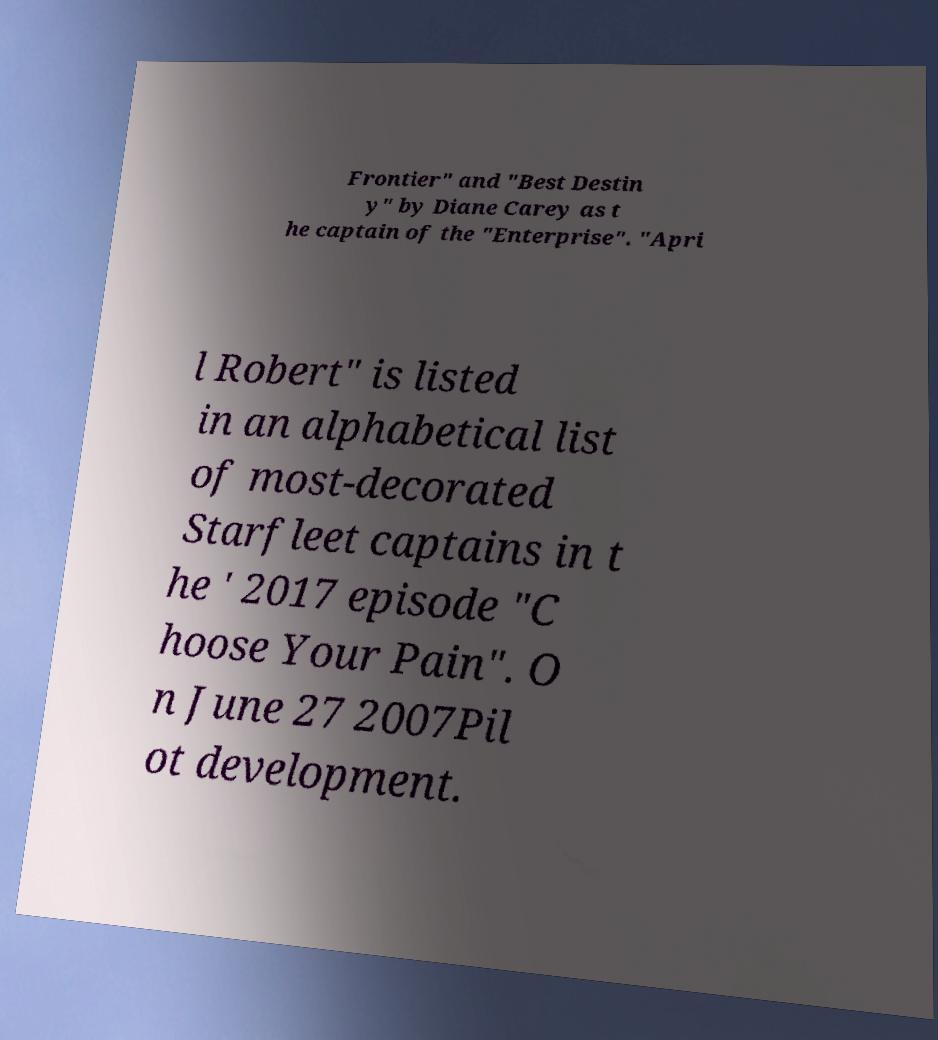For documentation purposes, I need the text within this image transcribed. Could you provide that? Frontier" and "Best Destin y" by Diane Carey as t he captain of the "Enterprise". "Apri l Robert" is listed in an alphabetical list of most-decorated Starfleet captains in t he ' 2017 episode "C hoose Your Pain". O n June 27 2007Pil ot development. 